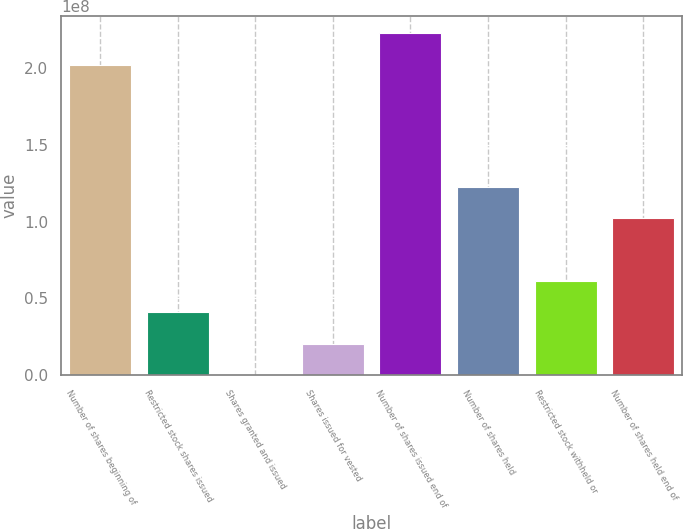<chart> <loc_0><loc_0><loc_500><loc_500><bar_chart><fcel>Number of shares beginning of<fcel>Restricted stock shares issued<fcel>Shares granted and issued<fcel>Shares issued for vested<fcel>Number of shares issued end of<fcel>Number of shares held<fcel>Restricted stock withheld or<fcel>Number of shares held end of<nl><fcel>2.02529e+08<fcel>4.09624e+07<fcel>37824<fcel>2.05001e+07<fcel>2.22991e+08<fcel>1.22812e+08<fcel>6.14247e+07<fcel>1.02349e+08<nl></chart> 